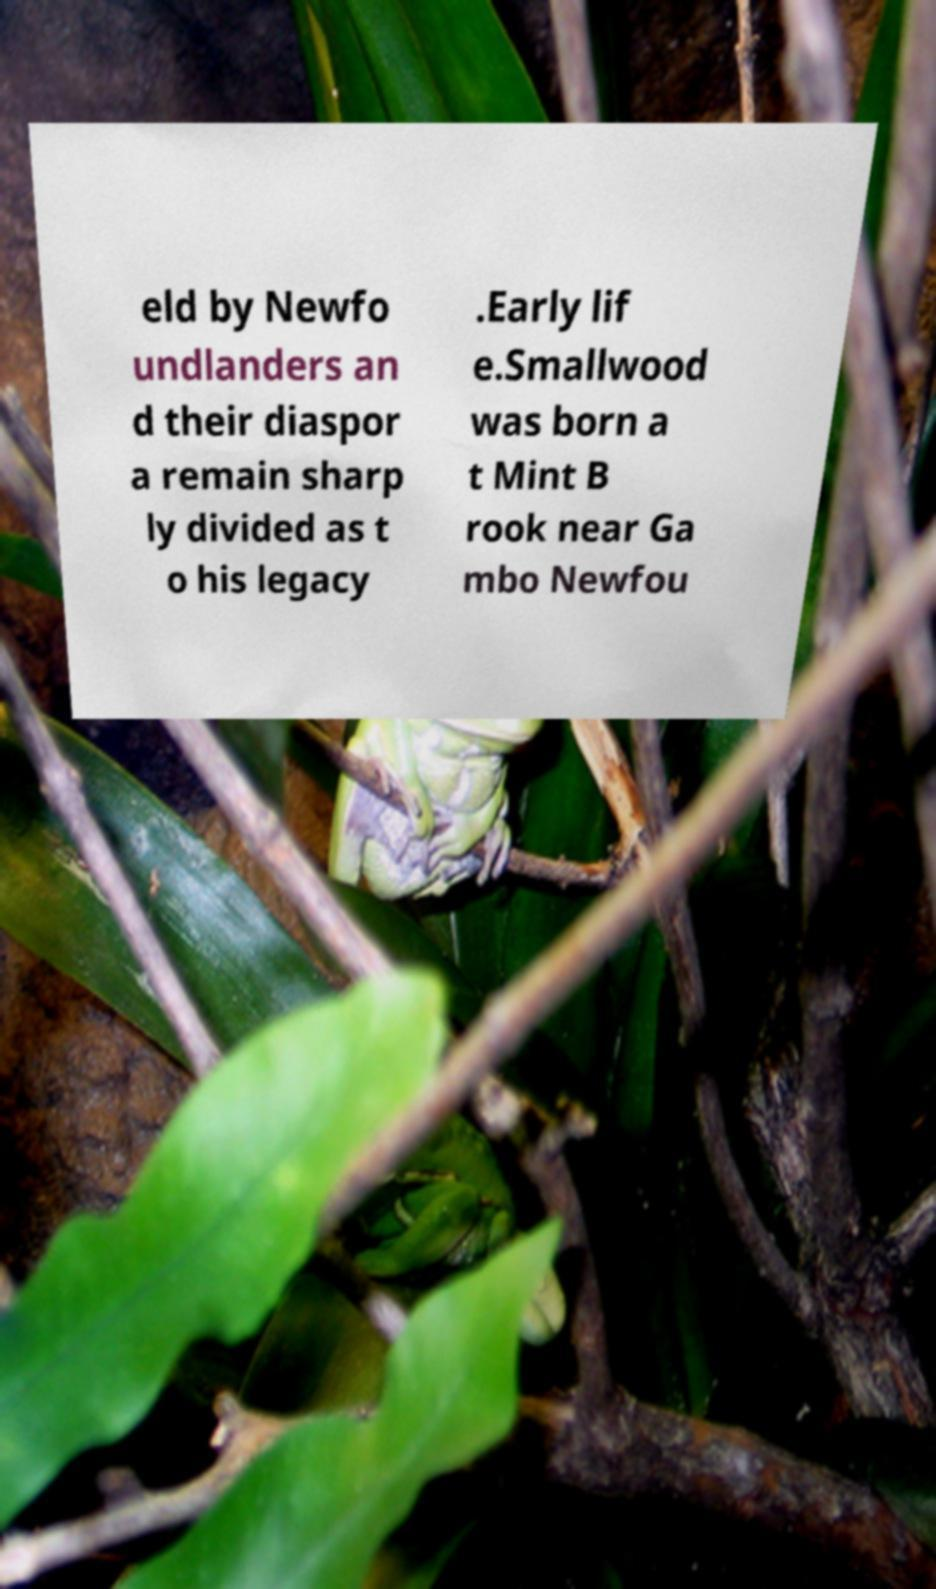Can you read and provide the text displayed in the image?This photo seems to have some interesting text. Can you extract and type it out for me? eld by Newfo undlanders an d their diaspor a remain sharp ly divided as t o his legacy .Early lif e.Smallwood was born a t Mint B rook near Ga mbo Newfou 